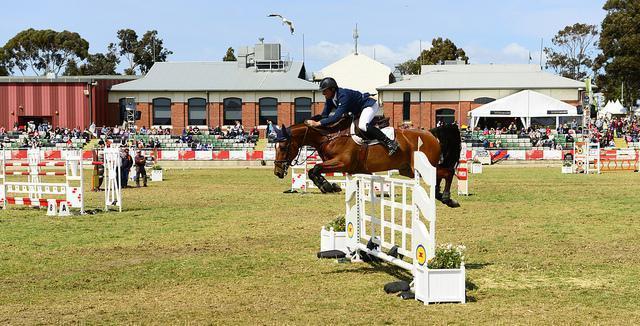What is the horse doing?
Pick the correct solution from the four options below to address the question.
Options: Sleeping, feeding, walking, leaping. Leaping. 